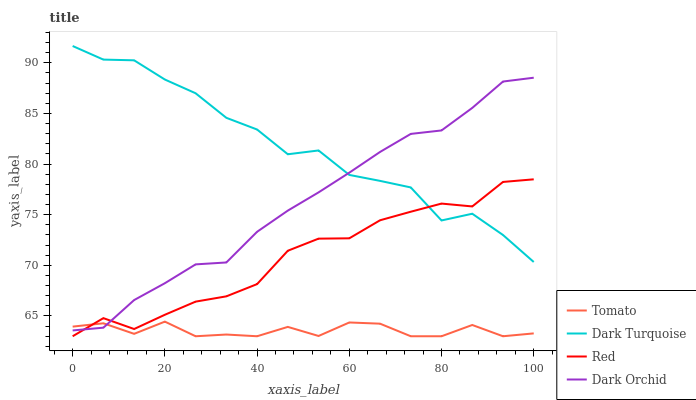Does Tomato have the minimum area under the curve?
Answer yes or no. Yes. Does Dark Turquoise have the maximum area under the curve?
Answer yes or no. Yes. Does Dark Orchid have the minimum area under the curve?
Answer yes or no. No. Does Dark Orchid have the maximum area under the curve?
Answer yes or no. No. Is Dark Orchid the smoothest?
Answer yes or no. Yes. Is Dark Turquoise the roughest?
Answer yes or no. Yes. Is Dark Turquoise the smoothest?
Answer yes or no. No. Is Dark Orchid the roughest?
Answer yes or no. No. Does Tomato have the lowest value?
Answer yes or no. Yes. Does Dark Orchid have the lowest value?
Answer yes or no. No. Does Dark Turquoise have the highest value?
Answer yes or no. Yes. Does Dark Orchid have the highest value?
Answer yes or no. No. Is Tomato less than Dark Turquoise?
Answer yes or no. Yes. Is Dark Turquoise greater than Tomato?
Answer yes or no. Yes. Does Tomato intersect Dark Orchid?
Answer yes or no. Yes. Is Tomato less than Dark Orchid?
Answer yes or no. No. Is Tomato greater than Dark Orchid?
Answer yes or no. No. Does Tomato intersect Dark Turquoise?
Answer yes or no. No. 